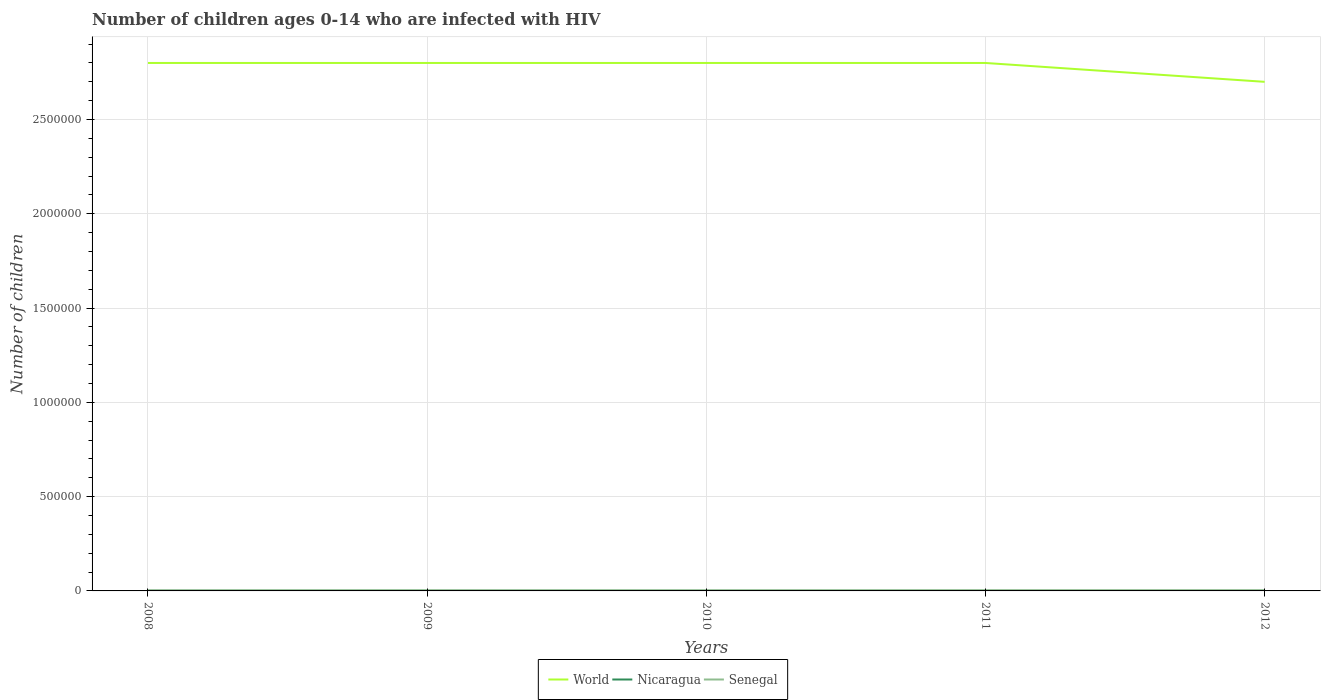How many different coloured lines are there?
Your response must be concise. 3. Does the line corresponding to Nicaragua intersect with the line corresponding to Senegal?
Make the answer very short. No. Across all years, what is the maximum number of HIV infected children in Nicaragua?
Ensure brevity in your answer.  500. What is the total number of HIV infected children in World in the graph?
Ensure brevity in your answer.  1.00e+05. What is the difference between the highest and the second highest number of HIV infected children in World?
Ensure brevity in your answer.  1.00e+05. What is the difference between the highest and the lowest number of HIV infected children in World?
Offer a very short reply. 4. How many lines are there?
Make the answer very short. 3. How many years are there in the graph?
Ensure brevity in your answer.  5. Are the values on the major ticks of Y-axis written in scientific E-notation?
Provide a short and direct response. No. Does the graph contain grids?
Provide a short and direct response. Yes. How many legend labels are there?
Keep it short and to the point. 3. How are the legend labels stacked?
Provide a short and direct response. Horizontal. What is the title of the graph?
Give a very brief answer. Number of children ages 0-14 who are infected with HIV. What is the label or title of the Y-axis?
Make the answer very short. Number of children. What is the Number of children of World in 2008?
Give a very brief answer. 2.80e+06. What is the Number of children in Nicaragua in 2008?
Ensure brevity in your answer.  1000. What is the Number of children in Senegal in 2008?
Give a very brief answer. 3400. What is the Number of children in World in 2009?
Make the answer very short. 2.80e+06. What is the Number of children in Senegal in 2009?
Give a very brief answer. 3500. What is the Number of children of World in 2010?
Ensure brevity in your answer.  2.80e+06. What is the Number of children in Nicaragua in 2010?
Provide a succinct answer. 500. What is the Number of children in Senegal in 2010?
Offer a terse response. 3600. What is the Number of children of World in 2011?
Offer a terse response. 2.80e+06. What is the Number of children of Nicaragua in 2011?
Keep it short and to the point. 500. What is the Number of children in Senegal in 2011?
Your answer should be compact. 3800. What is the Number of children in World in 2012?
Your response must be concise. 2.70e+06. What is the Number of children in Senegal in 2012?
Your answer should be very brief. 3800. Across all years, what is the maximum Number of children in World?
Keep it short and to the point. 2.80e+06. Across all years, what is the maximum Number of children in Senegal?
Offer a very short reply. 3800. Across all years, what is the minimum Number of children in World?
Offer a very short reply. 2.70e+06. Across all years, what is the minimum Number of children in Senegal?
Offer a very short reply. 3400. What is the total Number of children of World in the graph?
Make the answer very short. 1.39e+07. What is the total Number of children in Nicaragua in the graph?
Offer a very short reply. 3500. What is the total Number of children in Senegal in the graph?
Give a very brief answer. 1.81e+04. What is the difference between the Number of children in World in 2008 and that in 2009?
Your answer should be very brief. 0. What is the difference between the Number of children of Nicaragua in 2008 and that in 2009?
Give a very brief answer. 0. What is the difference between the Number of children of Senegal in 2008 and that in 2009?
Keep it short and to the point. -100. What is the difference between the Number of children in Senegal in 2008 and that in 2010?
Provide a succinct answer. -200. What is the difference between the Number of children in Senegal in 2008 and that in 2011?
Your answer should be compact. -400. What is the difference between the Number of children of Senegal in 2008 and that in 2012?
Give a very brief answer. -400. What is the difference between the Number of children of World in 2009 and that in 2010?
Make the answer very short. 0. What is the difference between the Number of children of Senegal in 2009 and that in 2010?
Provide a short and direct response. -100. What is the difference between the Number of children of World in 2009 and that in 2011?
Offer a very short reply. 0. What is the difference between the Number of children in Senegal in 2009 and that in 2011?
Your response must be concise. -300. What is the difference between the Number of children in Nicaragua in 2009 and that in 2012?
Make the answer very short. 500. What is the difference between the Number of children in Senegal in 2009 and that in 2012?
Your answer should be compact. -300. What is the difference between the Number of children of World in 2010 and that in 2011?
Your answer should be very brief. 0. What is the difference between the Number of children of Senegal in 2010 and that in 2011?
Offer a terse response. -200. What is the difference between the Number of children in Nicaragua in 2010 and that in 2012?
Provide a succinct answer. 0. What is the difference between the Number of children in Senegal in 2010 and that in 2012?
Offer a terse response. -200. What is the difference between the Number of children of World in 2011 and that in 2012?
Your answer should be compact. 1.00e+05. What is the difference between the Number of children in Senegal in 2011 and that in 2012?
Your answer should be compact. 0. What is the difference between the Number of children in World in 2008 and the Number of children in Nicaragua in 2009?
Your answer should be very brief. 2.80e+06. What is the difference between the Number of children of World in 2008 and the Number of children of Senegal in 2009?
Provide a short and direct response. 2.80e+06. What is the difference between the Number of children of Nicaragua in 2008 and the Number of children of Senegal in 2009?
Your answer should be very brief. -2500. What is the difference between the Number of children of World in 2008 and the Number of children of Nicaragua in 2010?
Ensure brevity in your answer.  2.80e+06. What is the difference between the Number of children of World in 2008 and the Number of children of Senegal in 2010?
Provide a succinct answer. 2.80e+06. What is the difference between the Number of children in Nicaragua in 2008 and the Number of children in Senegal in 2010?
Your response must be concise. -2600. What is the difference between the Number of children of World in 2008 and the Number of children of Nicaragua in 2011?
Offer a very short reply. 2.80e+06. What is the difference between the Number of children in World in 2008 and the Number of children in Senegal in 2011?
Offer a terse response. 2.80e+06. What is the difference between the Number of children in Nicaragua in 2008 and the Number of children in Senegal in 2011?
Keep it short and to the point. -2800. What is the difference between the Number of children in World in 2008 and the Number of children in Nicaragua in 2012?
Provide a short and direct response. 2.80e+06. What is the difference between the Number of children of World in 2008 and the Number of children of Senegal in 2012?
Ensure brevity in your answer.  2.80e+06. What is the difference between the Number of children in Nicaragua in 2008 and the Number of children in Senegal in 2012?
Keep it short and to the point. -2800. What is the difference between the Number of children of World in 2009 and the Number of children of Nicaragua in 2010?
Offer a very short reply. 2.80e+06. What is the difference between the Number of children in World in 2009 and the Number of children in Senegal in 2010?
Give a very brief answer. 2.80e+06. What is the difference between the Number of children in Nicaragua in 2009 and the Number of children in Senegal in 2010?
Ensure brevity in your answer.  -2600. What is the difference between the Number of children in World in 2009 and the Number of children in Nicaragua in 2011?
Provide a short and direct response. 2.80e+06. What is the difference between the Number of children in World in 2009 and the Number of children in Senegal in 2011?
Your answer should be compact. 2.80e+06. What is the difference between the Number of children of Nicaragua in 2009 and the Number of children of Senegal in 2011?
Your answer should be compact. -2800. What is the difference between the Number of children of World in 2009 and the Number of children of Nicaragua in 2012?
Provide a succinct answer. 2.80e+06. What is the difference between the Number of children of World in 2009 and the Number of children of Senegal in 2012?
Your answer should be very brief. 2.80e+06. What is the difference between the Number of children in Nicaragua in 2009 and the Number of children in Senegal in 2012?
Make the answer very short. -2800. What is the difference between the Number of children in World in 2010 and the Number of children in Nicaragua in 2011?
Provide a succinct answer. 2.80e+06. What is the difference between the Number of children of World in 2010 and the Number of children of Senegal in 2011?
Keep it short and to the point. 2.80e+06. What is the difference between the Number of children of Nicaragua in 2010 and the Number of children of Senegal in 2011?
Ensure brevity in your answer.  -3300. What is the difference between the Number of children in World in 2010 and the Number of children in Nicaragua in 2012?
Give a very brief answer. 2.80e+06. What is the difference between the Number of children of World in 2010 and the Number of children of Senegal in 2012?
Your answer should be compact. 2.80e+06. What is the difference between the Number of children in Nicaragua in 2010 and the Number of children in Senegal in 2012?
Your response must be concise. -3300. What is the difference between the Number of children in World in 2011 and the Number of children in Nicaragua in 2012?
Your answer should be very brief. 2.80e+06. What is the difference between the Number of children in World in 2011 and the Number of children in Senegal in 2012?
Make the answer very short. 2.80e+06. What is the difference between the Number of children in Nicaragua in 2011 and the Number of children in Senegal in 2012?
Provide a succinct answer. -3300. What is the average Number of children of World per year?
Provide a succinct answer. 2.78e+06. What is the average Number of children of Nicaragua per year?
Make the answer very short. 700. What is the average Number of children of Senegal per year?
Your response must be concise. 3620. In the year 2008, what is the difference between the Number of children of World and Number of children of Nicaragua?
Make the answer very short. 2.80e+06. In the year 2008, what is the difference between the Number of children of World and Number of children of Senegal?
Provide a short and direct response. 2.80e+06. In the year 2008, what is the difference between the Number of children in Nicaragua and Number of children in Senegal?
Give a very brief answer. -2400. In the year 2009, what is the difference between the Number of children of World and Number of children of Nicaragua?
Make the answer very short. 2.80e+06. In the year 2009, what is the difference between the Number of children in World and Number of children in Senegal?
Your answer should be compact. 2.80e+06. In the year 2009, what is the difference between the Number of children in Nicaragua and Number of children in Senegal?
Your answer should be compact. -2500. In the year 2010, what is the difference between the Number of children in World and Number of children in Nicaragua?
Provide a succinct answer. 2.80e+06. In the year 2010, what is the difference between the Number of children of World and Number of children of Senegal?
Offer a terse response. 2.80e+06. In the year 2010, what is the difference between the Number of children of Nicaragua and Number of children of Senegal?
Your answer should be compact. -3100. In the year 2011, what is the difference between the Number of children of World and Number of children of Nicaragua?
Provide a succinct answer. 2.80e+06. In the year 2011, what is the difference between the Number of children of World and Number of children of Senegal?
Offer a very short reply. 2.80e+06. In the year 2011, what is the difference between the Number of children in Nicaragua and Number of children in Senegal?
Provide a succinct answer. -3300. In the year 2012, what is the difference between the Number of children in World and Number of children in Nicaragua?
Provide a succinct answer. 2.70e+06. In the year 2012, what is the difference between the Number of children of World and Number of children of Senegal?
Give a very brief answer. 2.70e+06. In the year 2012, what is the difference between the Number of children in Nicaragua and Number of children in Senegal?
Provide a succinct answer. -3300. What is the ratio of the Number of children in Nicaragua in 2008 to that in 2009?
Offer a terse response. 1. What is the ratio of the Number of children in Senegal in 2008 to that in 2009?
Offer a terse response. 0.97. What is the ratio of the Number of children of Nicaragua in 2008 to that in 2010?
Offer a very short reply. 2. What is the ratio of the Number of children of Nicaragua in 2008 to that in 2011?
Ensure brevity in your answer.  2. What is the ratio of the Number of children in Senegal in 2008 to that in 2011?
Your response must be concise. 0.89. What is the ratio of the Number of children of World in 2008 to that in 2012?
Provide a short and direct response. 1.04. What is the ratio of the Number of children in Senegal in 2008 to that in 2012?
Your answer should be compact. 0.89. What is the ratio of the Number of children in World in 2009 to that in 2010?
Your response must be concise. 1. What is the ratio of the Number of children in Senegal in 2009 to that in 2010?
Offer a terse response. 0.97. What is the ratio of the Number of children of World in 2009 to that in 2011?
Give a very brief answer. 1. What is the ratio of the Number of children in Senegal in 2009 to that in 2011?
Keep it short and to the point. 0.92. What is the ratio of the Number of children of World in 2009 to that in 2012?
Your answer should be very brief. 1.04. What is the ratio of the Number of children of Nicaragua in 2009 to that in 2012?
Provide a short and direct response. 2. What is the ratio of the Number of children of Senegal in 2009 to that in 2012?
Your response must be concise. 0.92. What is the ratio of the Number of children in Nicaragua in 2010 to that in 2012?
Your answer should be compact. 1. What is the ratio of the Number of children in Senegal in 2010 to that in 2012?
Provide a succinct answer. 0.95. What is the ratio of the Number of children in Nicaragua in 2011 to that in 2012?
Make the answer very short. 1. What is the difference between the highest and the second highest Number of children of World?
Make the answer very short. 0. What is the difference between the highest and the second highest Number of children of Nicaragua?
Provide a short and direct response. 0. What is the difference between the highest and the lowest Number of children of Nicaragua?
Keep it short and to the point. 500. 